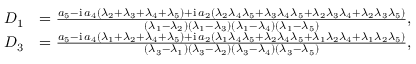Convert formula to latex. <formula><loc_0><loc_0><loc_500><loc_500>\begin{array} { r l } { D _ { 1 } } & { = \frac { a _ { 5 } - i \, a _ { 4 } ( \lambda _ { 2 } + \lambda _ { 3 } + \lambda _ { 4 } + \lambda _ { 5 } ) + i \, a _ { 2 } ( \lambda _ { 2 } \lambda _ { 4 } \lambda _ { 5 } + \lambda _ { 3 } \lambda _ { 4 } \lambda _ { 5 } + \lambda _ { 2 } \lambda _ { 3 } \lambda _ { 4 } + \lambda _ { 2 } \lambda _ { 3 } \lambda _ { 5 } ) } { ( \lambda _ { 1 } - \lambda _ { 2 } ) ( \lambda _ { 1 } - \lambda _ { 3 } ) ( \lambda _ { 1 } - \lambda _ { 4 } ) ( \lambda _ { 1 } - \lambda _ { 5 } ) } , } \\ { D _ { 3 } } & { = \frac { a _ { 5 } - i \, a _ { 4 } ( \lambda _ { 1 } + \lambda _ { 2 } + \lambda _ { 4 } + \lambda _ { 5 } ) + i \, a _ { 2 } ( \lambda _ { 1 } \lambda _ { 4 } \lambda _ { 5 } + \lambda _ { 2 } \lambda _ { 4 } \lambda _ { 5 } + \lambda _ { 1 } \lambda _ { 2 } \lambda _ { 4 } + \lambda _ { 1 } \lambda _ { 2 } \lambda _ { 5 } ) } { ( \lambda _ { 3 } - \lambda _ { 1 } ) ( \lambda _ { 3 } - \lambda _ { 2 } ) ( \lambda _ { 3 } - \lambda _ { 4 } ) ( \lambda _ { 3 } - \lambda _ { 5 } ) } , } \end{array}</formula> 